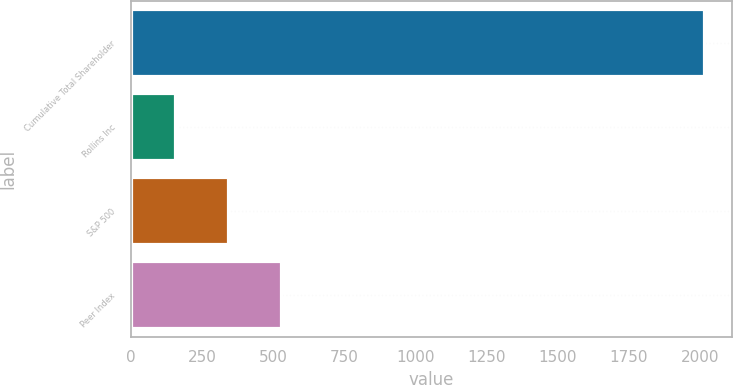<chart> <loc_0><loc_0><loc_500><loc_500><bar_chart><fcel>Cumulative Total Shareholder<fcel>Rollins Inc<fcel>S&P 500<fcel>Peer Index<nl><fcel>2014<fcel>157.19<fcel>342.87<fcel>528.55<nl></chart> 